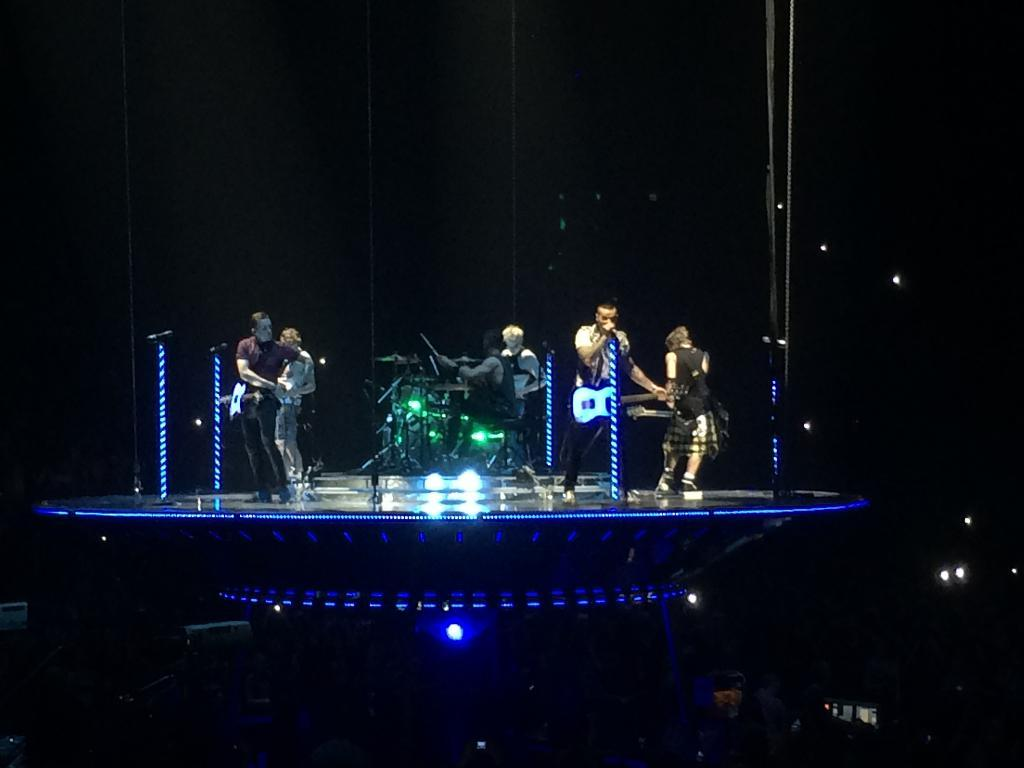What are the people in the image doing? The people in the image are playing musical instruments. Can you describe the setting in which the people are playing their instruments? There are lights visible in the image, specifically near a dais. What type of plantation can be seen in the background of the image? There is no plantation present in the image; it features people playing musical instruments with lights near a dais. 